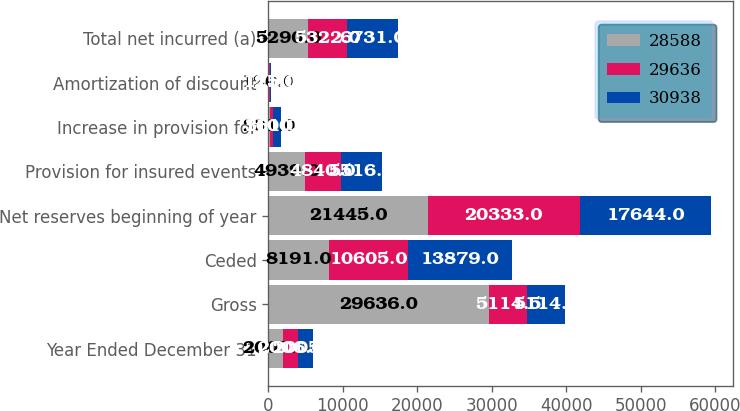<chart> <loc_0><loc_0><loc_500><loc_500><stacked_bar_chart><ecel><fcel>Year Ended December 31<fcel>Gross<fcel>Ceded<fcel>Net reserves beginning of year<fcel>Provision for insured events<fcel>Increase in provision for<fcel>Amortization of discount<fcel>Total net incurred (a)<nl><fcel>28588<fcel>2007<fcel>29636<fcel>8191<fcel>21445<fcel>4939<fcel>231<fcel>120<fcel>5290<nl><fcel>29636<fcel>2006<fcel>5114.5<fcel>10605<fcel>20333<fcel>4840<fcel>361<fcel>121<fcel>5322<nl><fcel>30938<fcel>2005<fcel>5114.5<fcel>13879<fcel>17644<fcel>5516<fcel>1100<fcel>115<fcel>6731<nl></chart> 